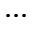Convert formula to latex. <formula><loc_0><loc_0><loc_500><loc_500>\dots</formula> 